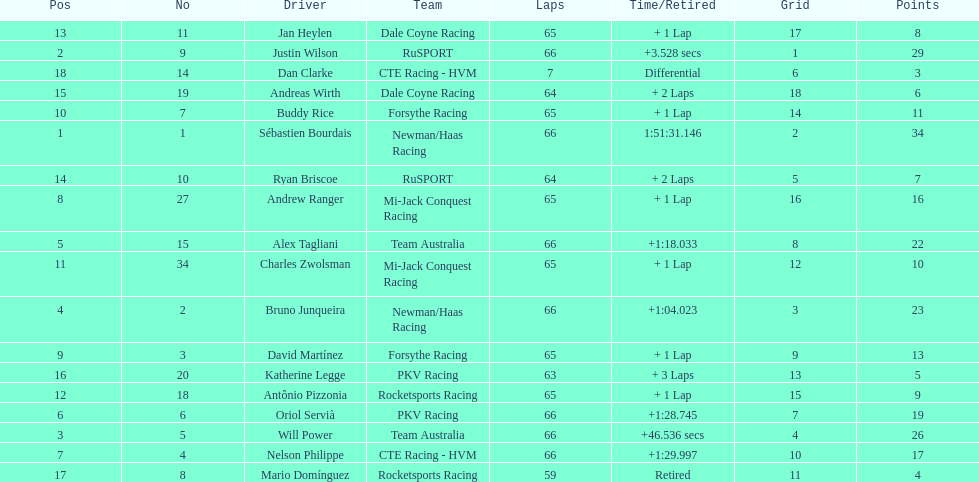At the 2006 gran premio telmex, did oriol servia or katherine legge complete more laps? Oriol Servià. 